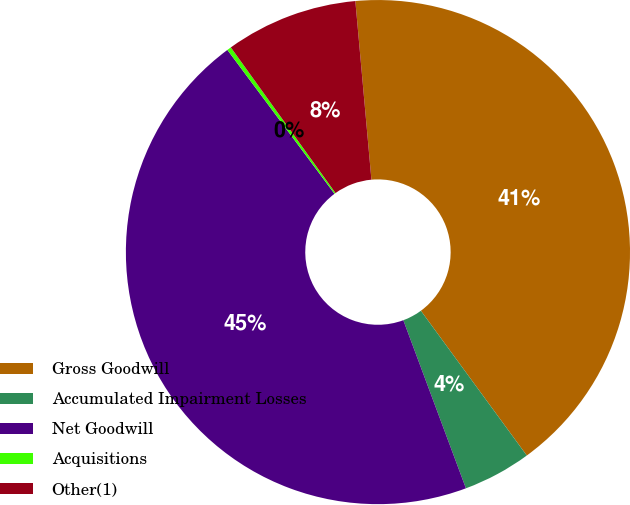<chart> <loc_0><loc_0><loc_500><loc_500><pie_chart><fcel>Gross Goodwill<fcel>Accumulated Impairment Losses<fcel>Net Goodwill<fcel>Acquisitions<fcel>Other(1)<nl><fcel>41.38%<fcel>4.38%<fcel>45.49%<fcel>0.27%<fcel>8.49%<nl></chart> 